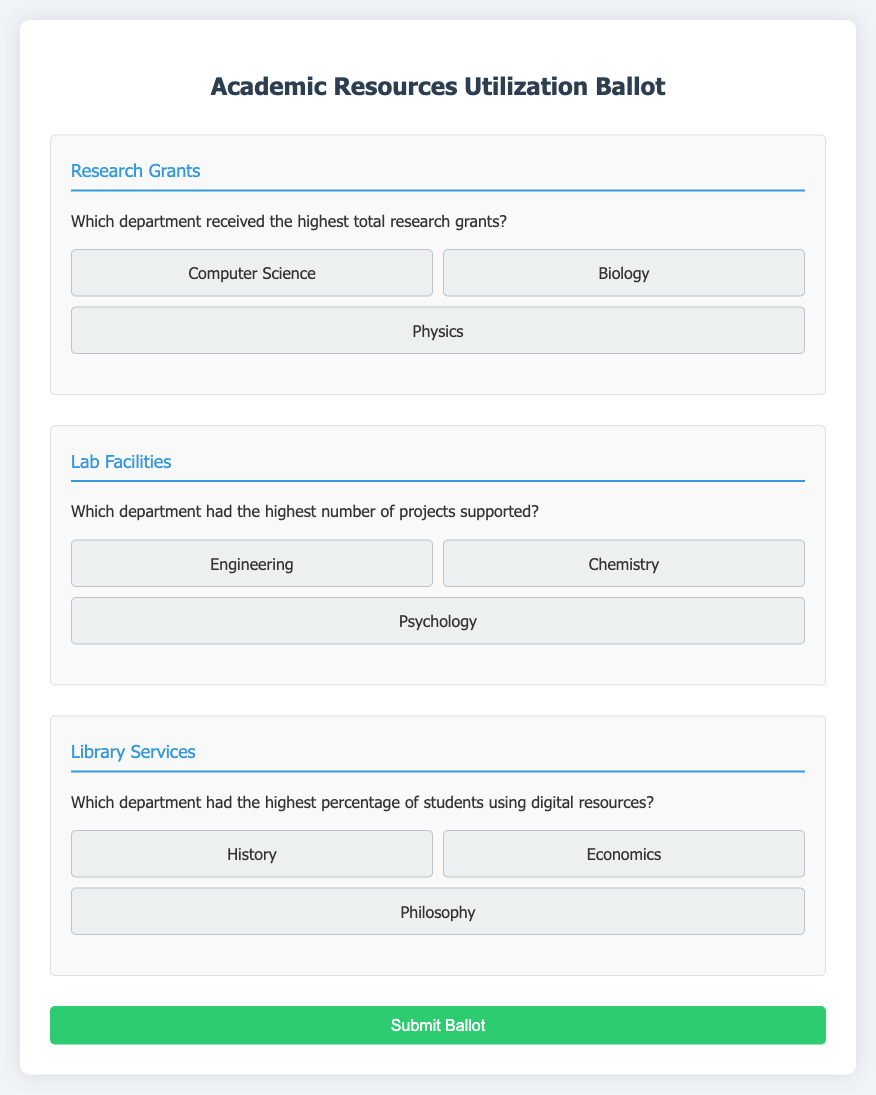Which department received the highest total research grants? This question asks for a specific detail regarding research grants highlighted in the ballot.
Answer: Computer Science Which department had the highest number of projects supported? This question seeks information about lab facilities and which department had the most project support.
Answer: Engineering Which department had the highest percentage of students using digital resources? This question is about library services and which department utilized digital resources the most.
Answer: History What is the title of the ballot? This question inquires about the heading of the document, which describes what the content is about.
Answer: Academic Resources Utilization Ballot How many sections are there in the ballot? This question asks about the organization of the document, specifically the number of distinct sections presented.
Answer: Three 